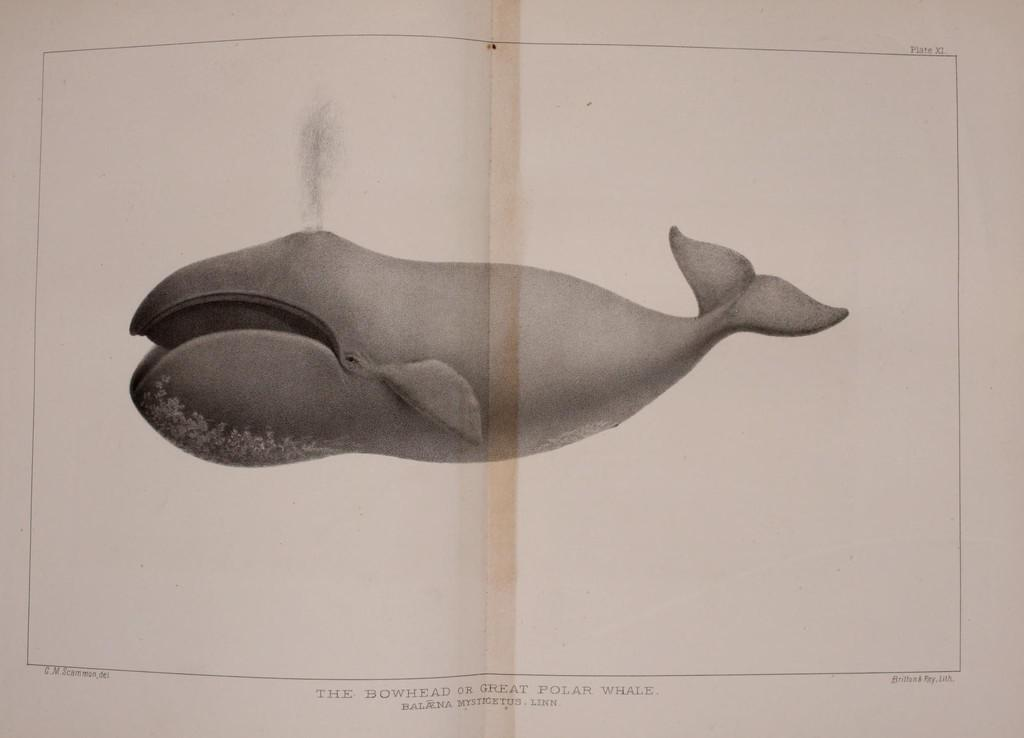What is depicted on the paper in the image? There is a whale picture on the paper. What can be seen at the top of the paper? There is writing at the top of the paper. What can be seen at the bottom of the paper? There is writing at the bottom of the paper. Can you see a plane flying in the image? There is no plane visible in the image; it only features a whale picture on a paper with writing at the top and bottom. 